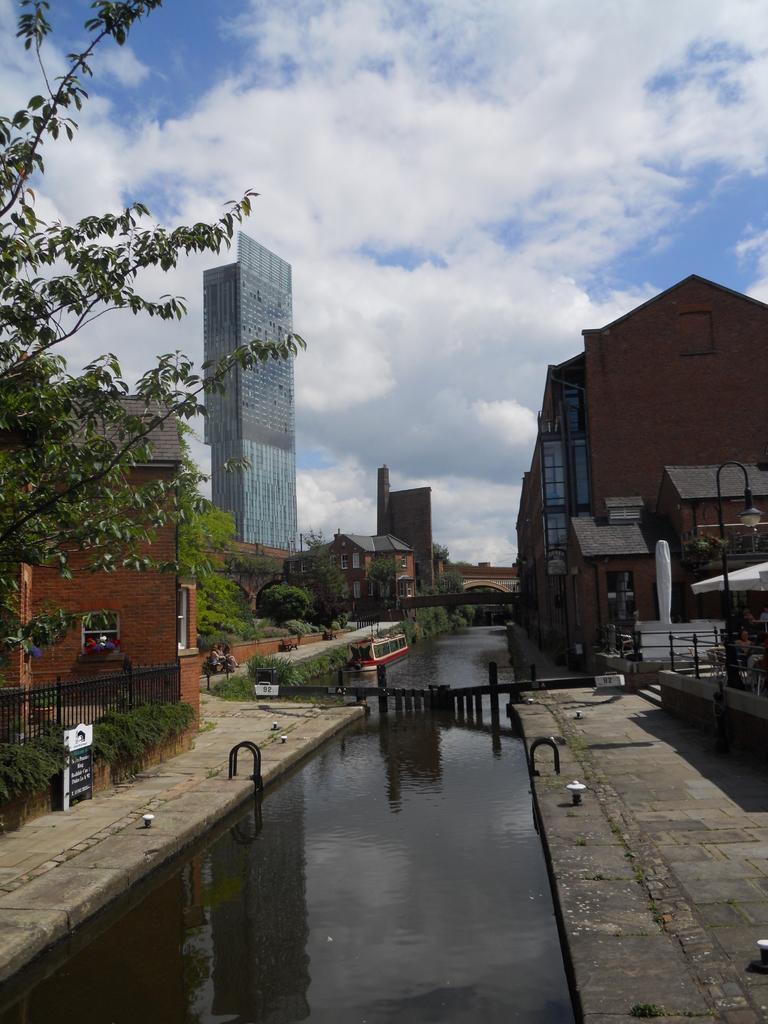In one or two sentences, can you explain what this image depicts? In this picture there are buildings and trees. On the right side of the image there is a tent. On the left side of the image there is a railing and there is a board and there is a boat on the water. In the middle of the image there is water. At the top there is sky and there are clouds. 